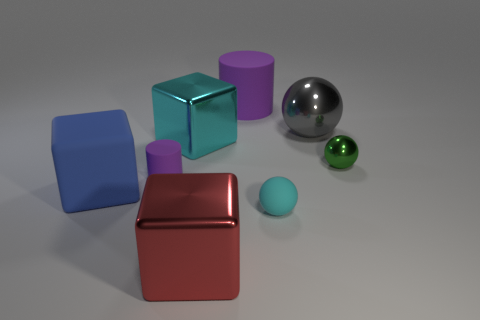Add 2 large matte blocks. How many objects exist? 10 Subtract all blocks. How many objects are left? 5 Add 3 big rubber cubes. How many big rubber cubes are left? 4 Add 4 brown cylinders. How many brown cylinders exist? 4 Subtract 1 cyan cubes. How many objects are left? 7 Subtract all cyan cubes. Subtract all tiny cyan shiny cylinders. How many objects are left? 7 